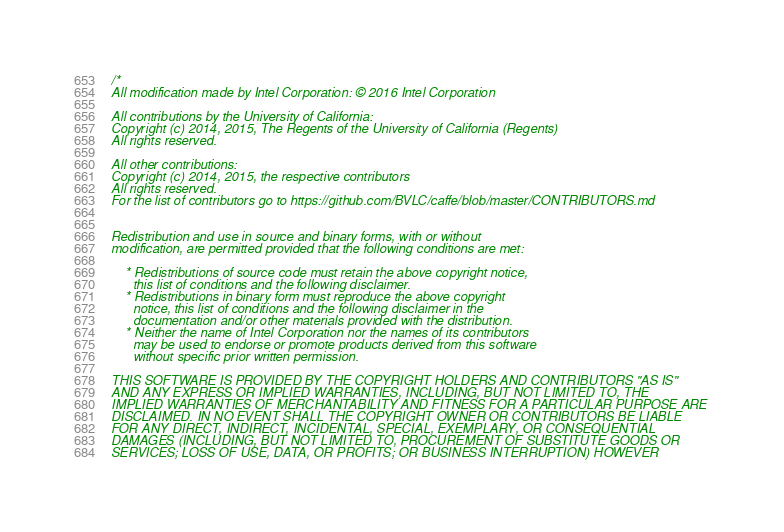Convert code to text. <code><loc_0><loc_0><loc_500><loc_500><_C++_>/*
All modification made by Intel Corporation: © 2016 Intel Corporation

All contributions by the University of California:
Copyright (c) 2014, 2015, The Regents of the University of California (Regents)
All rights reserved.

All other contributions:
Copyright (c) 2014, 2015, the respective contributors
All rights reserved.
For the list of contributors go to https://github.com/BVLC/caffe/blob/master/CONTRIBUTORS.md


Redistribution and use in source and binary forms, with or without
modification, are permitted provided that the following conditions are met:

    * Redistributions of source code must retain the above copyright notice,
      this list of conditions and the following disclaimer.
    * Redistributions in binary form must reproduce the above copyright
      notice, this list of conditions and the following disclaimer in the
      documentation and/or other materials provided with the distribution.
    * Neither the name of Intel Corporation nor the names of its contributors
      may be used to endorse or promote products derived from this software
      without specific prior written permission.

THIS SOFTWARE IS PROVIDED BY THE COPYRIGHT HOLDERS AND CONTRIBUTORS "AS IS"
AND ANY EXPRESS OR IMPLIED WARRANTIES, INCLUDING, BUT NOT LIMITED TO, THE
IMPLIED WARRANTIES OF MERCHANTABILITY AND FITNESS FOR A PARTICULAR PURPOSE ARE
DISCLAIMED. IN NO EVENT SHALL THE COPYRIGHT OWNER OR CONTRIBUTORS BE LIABLE
FOR ANY DIRECT, INDIRECT, INCIDENTAL, SPECIAL, EXEMPLARY, OR CONSEQUENTIAL
DAMAGES (INCLUDING, BUT NOT LIMITED TO, PROCUREMENT OF SUBSTITUTE GOODS OR
SERVICES; LOSS OF USE, DATA, OR PROFITS; OR BUSINESS INTERRUPTION) HOWEVER</code> 